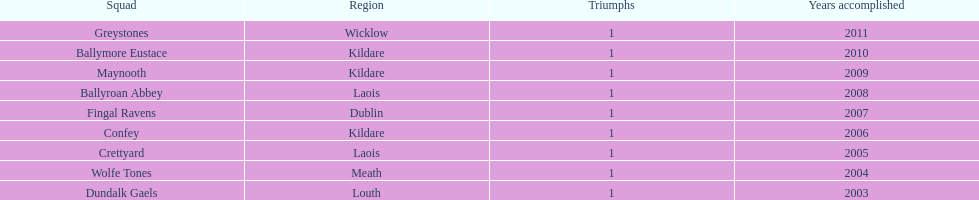In which county were the highest number of victories recorded? Kildare. 